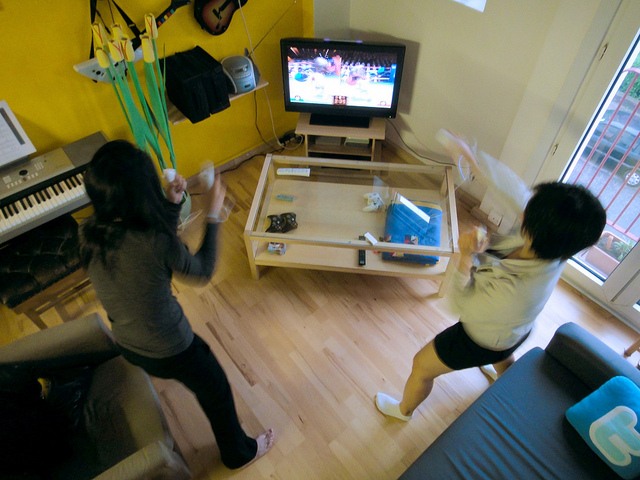Please transcribe the text in this image. t 